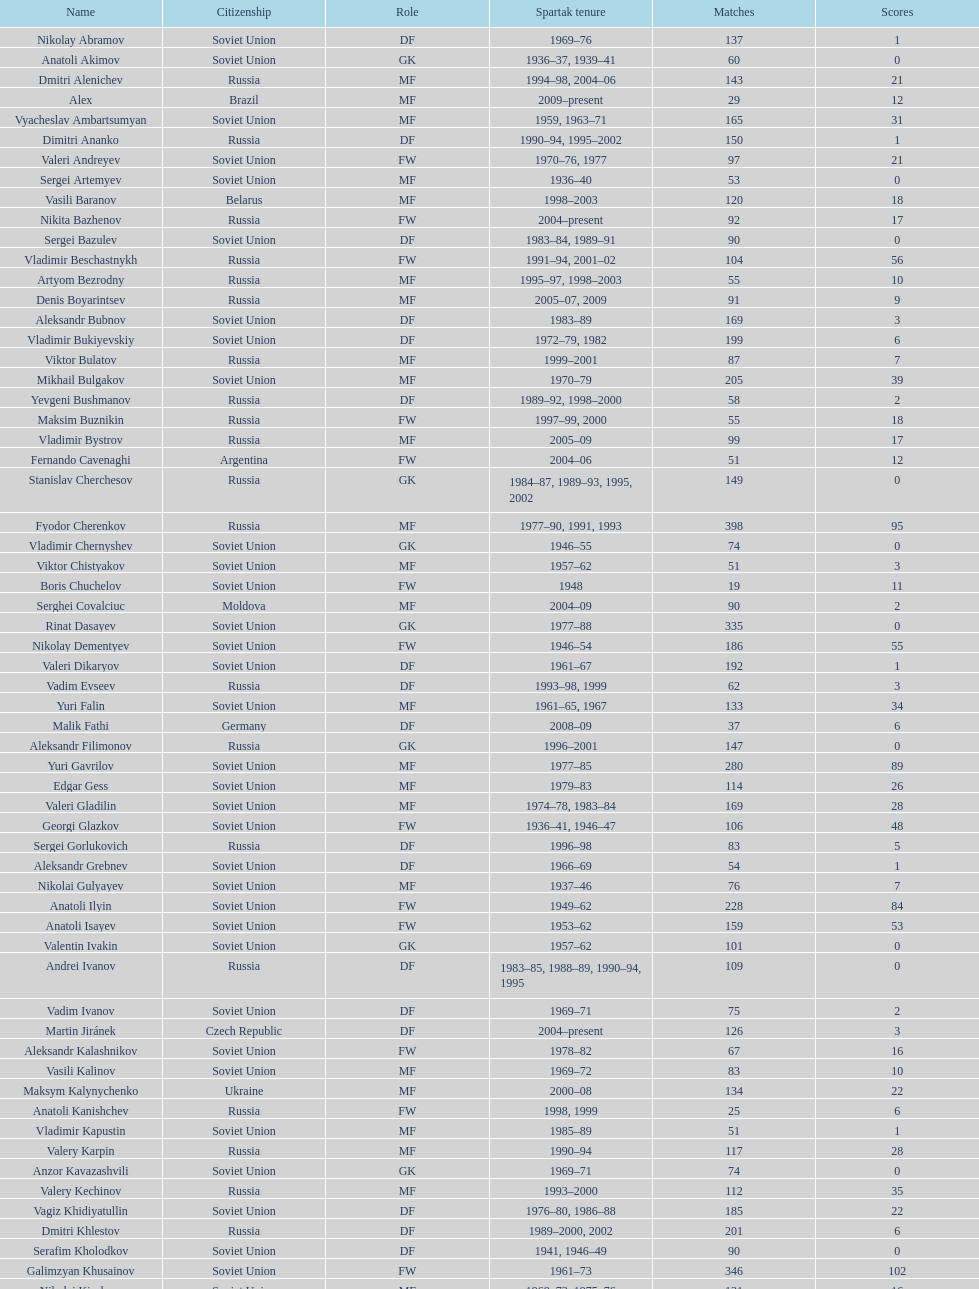Vladimir bukiyevskiy had how many appearances? 199. 